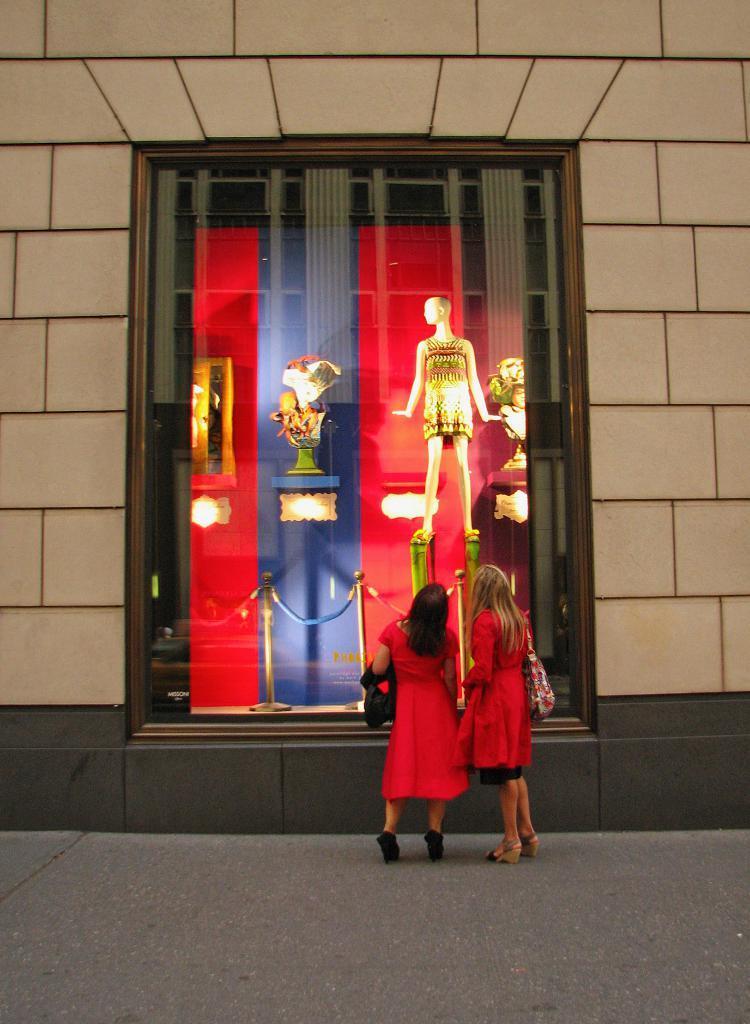Describe this image in one or two sentences. In this picture we can see there are two women in the red dresses are standing on the floor. In front of the women there is the wall and there are poles with ropes, a mannequin and some objects in the transparent glass object. 